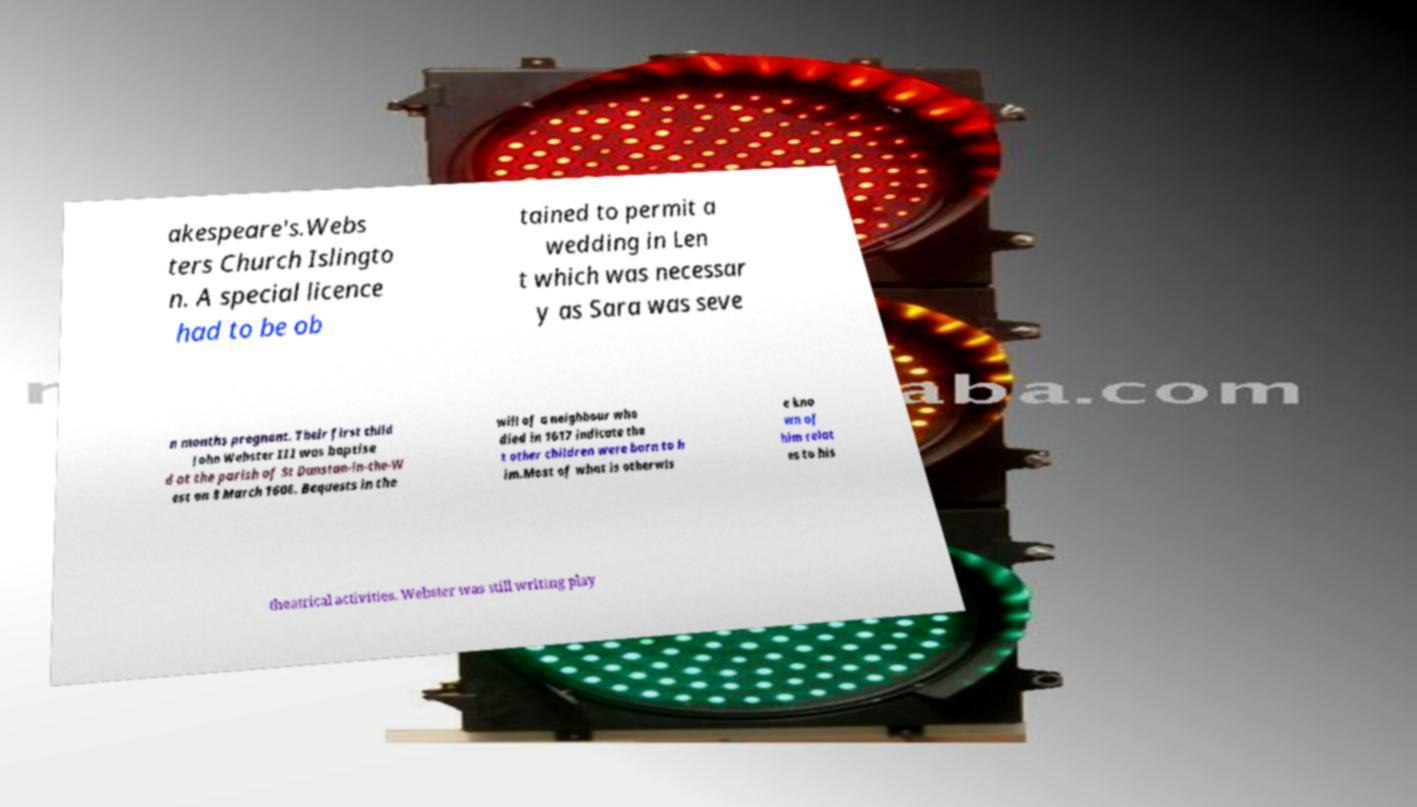I need the written content from this picture converted into text. Can you do that? akespeare's.Webs ters Church Islingto n. A special licence had to be ob tained to permit a wedding in Len t which was necessar y as Sara was seve n months pregnant. Their first child John Webster III was baptise d at the parish of St Dunstan-in-the-W est on 8 March 1606. Bequests in the will of a neighbour who died in 1617 indicate tha t other children were born to h im.Most of what is otherwis e kno wn of him relat es to his theatrical activities. Webster was still writing play 